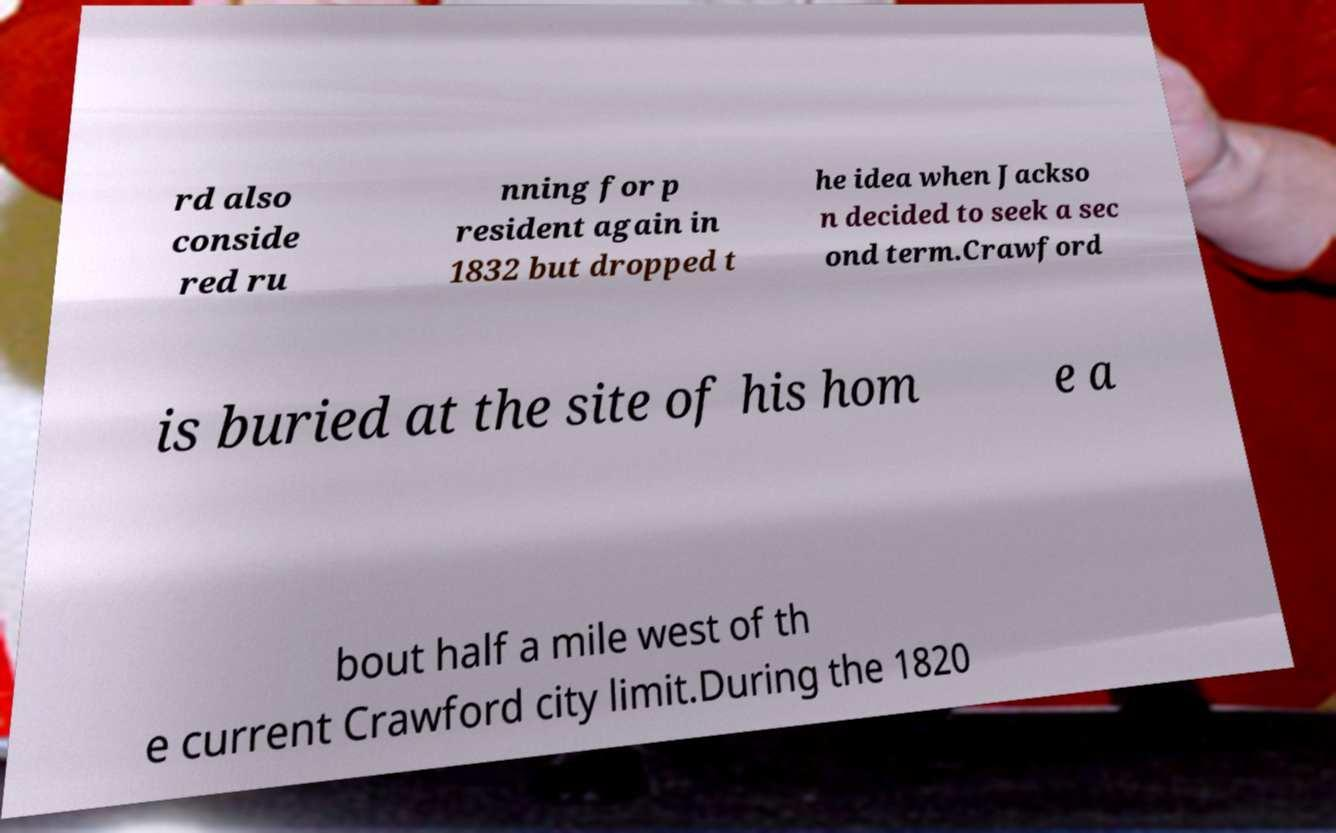Please identify and transcribe the text found in this image. rd also conside red ru nning for p resident again in 1832 but dropped t he idea when Jackso n decided to seek a sec ond term.Crawford is buried at the site of his hom e a bout half a mile west of th e current Crawford city limit.During the 1820 